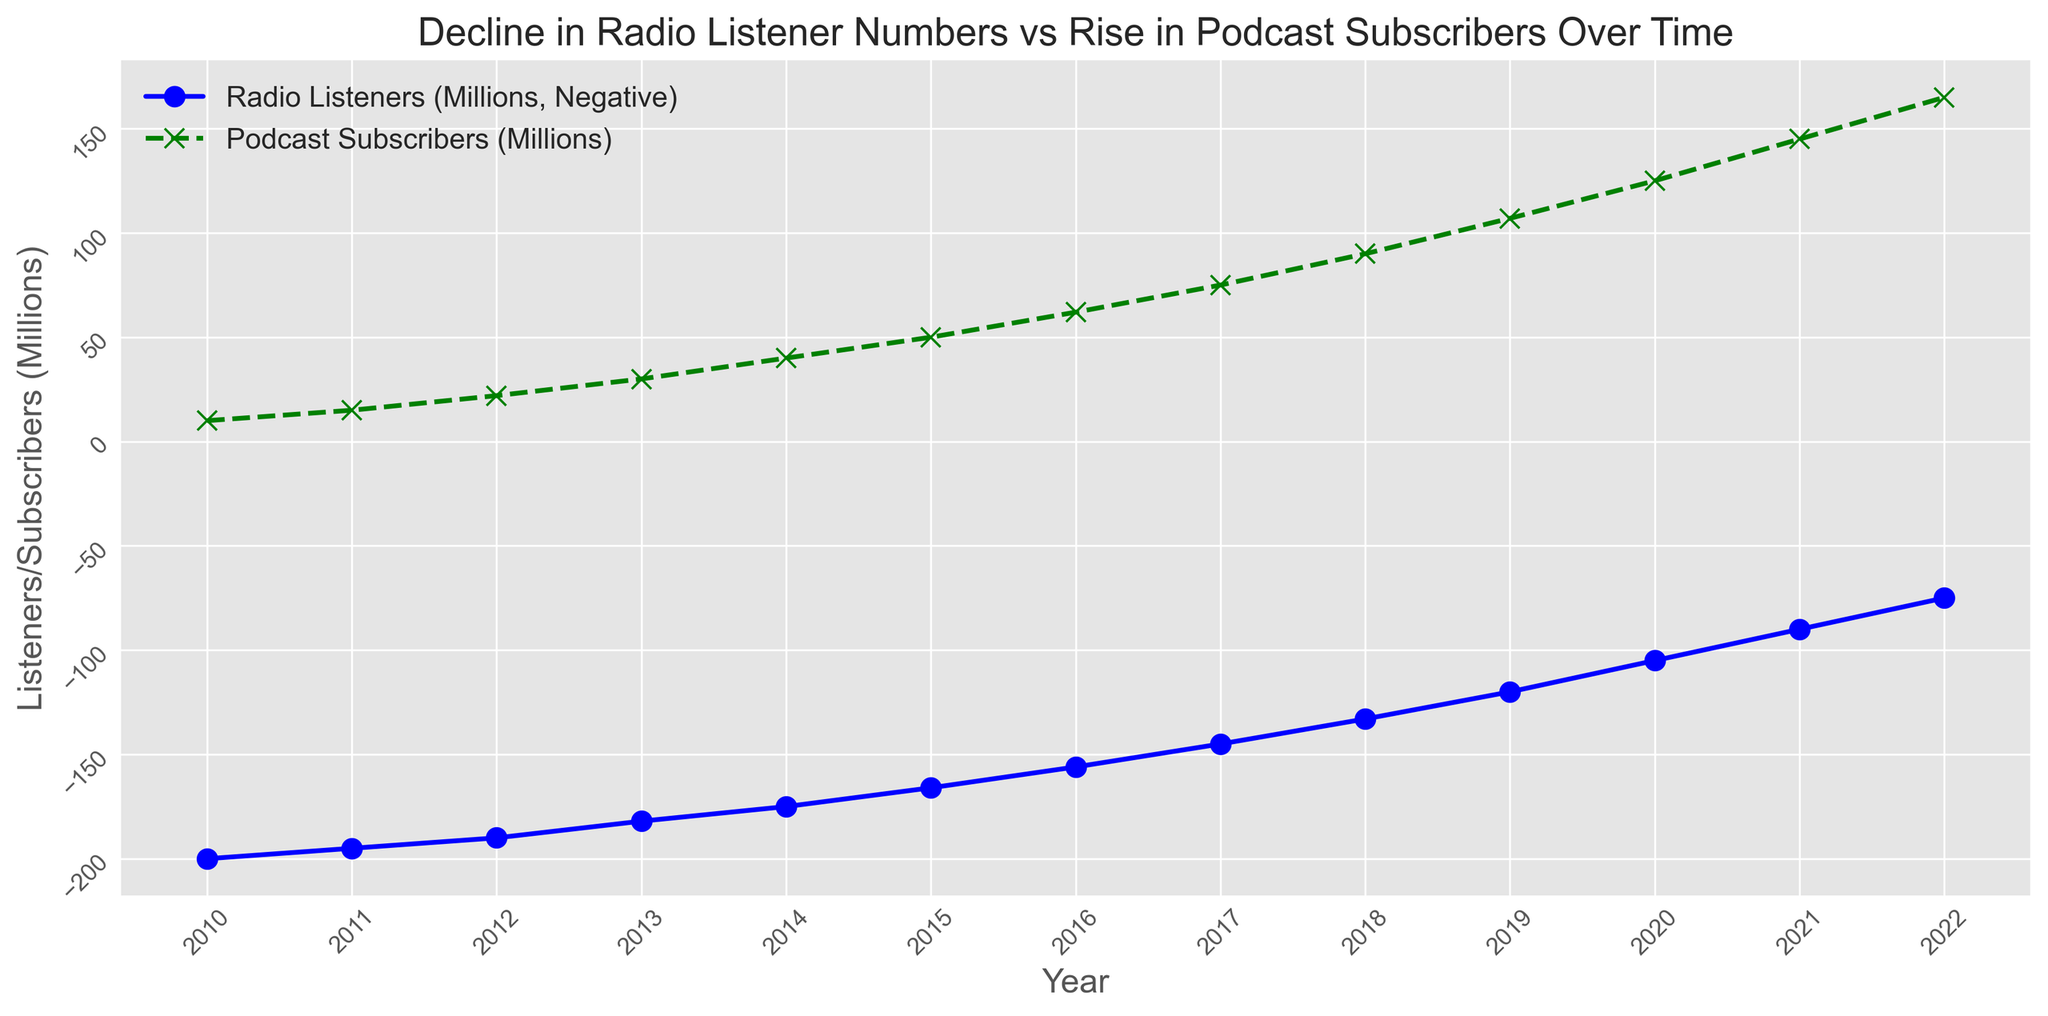What trend can be observed in radio listeners from 2010 to 2022? By examining the negative trend of the blue line representing 'Radio Listeners (Millions, Negative)' over time, we see a consistent decline from 2010 to 2022.
Answer: A consistent decline What trend can be observed in podcast subscribers from 2010 to 2022? By looking at the upward trend of the green line representing 'Podcast Subscribers (Millions)' over time, we notice a continuous increase from 2010 to 2022.
Answer: A continuous increase In which year did podcast subscribers surpass 100 million? By looking at the green line representing 'Podcast Subscribers (Millions)', we can see that it crosses the 100 million mark between 2018 and 2019.
Answer: 2019 What was the difference in radio listeners between 2010 and 2022? The blue line starts at 200 million in 2010 and drops to 75 million in 2022. The difference is 200 - 75 = 125 million.
Answer: 125 million Which year experienced the steepest decline in radio listeners? By observing the slope of the blue line representing 'Radio Listeners (Millions, Negative)', the most noticeable steep decline appears between 2019 and 2020.
Answer: 2019 to 2020 How many more podcast subscribers were there in 2022 compared to 2010? In 2010, there were 10 million subscribers, and in 2022, there were 165 million. The increase is 165 - 10 = 155 million.
Answer: 155 million Was there any year where radio listeners and podcast subscribers were approximately equal? By observing the lines closely, there is no point at which the values for radio listeners and podcast subscribers intersect or come close; radio listeners always exceed podcast subscribers.
Answer: No What can be concluded about the relationship between radio listener decline and podcast subscriber rise over time? By comparing the trends of the two lines, as the blue line for radio listeners declines consistently, the green line for podcast subscribers rises. This suggests that as fewer people listen to radio, more people subscribe to podcasts.
Answer: As radio listeners decline, podcast subscribers rise 